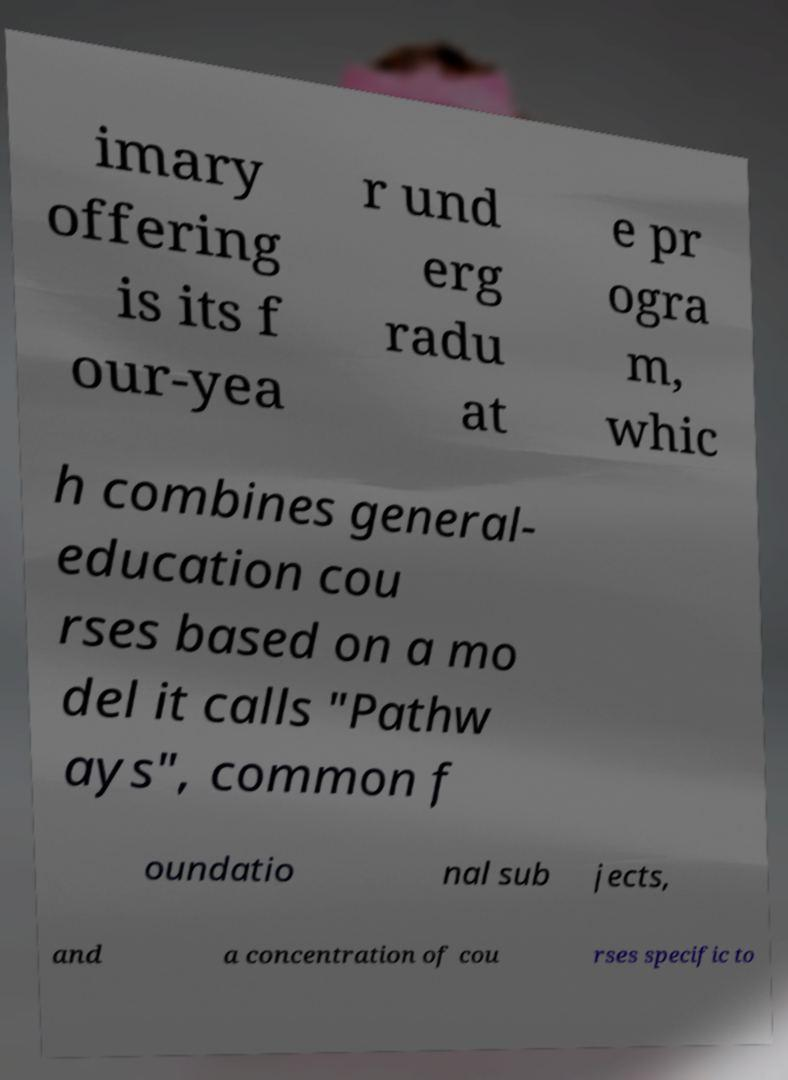For documentation purposes, I need the text within this image transcribed. Could you provide that? imary offering is its f our-yea r und erg radu at e pr ogra m, whic h combines general- education cou rses based on a mo del it calls "Pathw ays", common f oundatio nal sub jects, and a concentration of cou rses specific to 